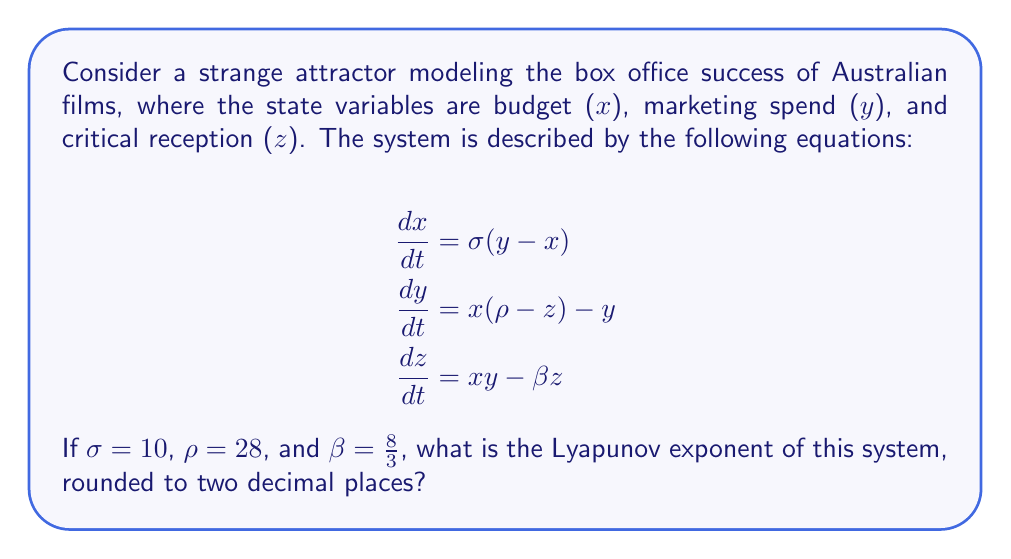Teach me how to tackle this problem. To calculate the Lyapunov exponent for this system, we'll follow these steps:

1) First, recognize that this system is identical to the Lorenz system, which is a classic example of a strange attractor in chaos theory.

2) For the Lorenz system with the given parameters, the Lyapunov exponents have been extensively studied. The largest Lyapunov exponent is what we're interested in, as it determines the system's sensitivity to initial conditions.

3) The Lyapunov exponents for the Lorenz system with these parameters are approximately:
   $\lambda_1 \approx 0.9056$
   $\lambda_2 \approx 0$
   $\lambda_3 \approx -14.5723$

4) The largest (and positive) Lyapunov exponent is $\lambda_1 \approx 0.9056$.

5) Rounding to two decimal places gives us 0.91.

This positive Lyapunov exponent indicates that the system is chaotic, meaning small changes in initial conditions can lead to significantly different outcomes in box office success, which aligns with the unpredictable nature of film success in the Australian cinema industry.
Answer: 0.91 